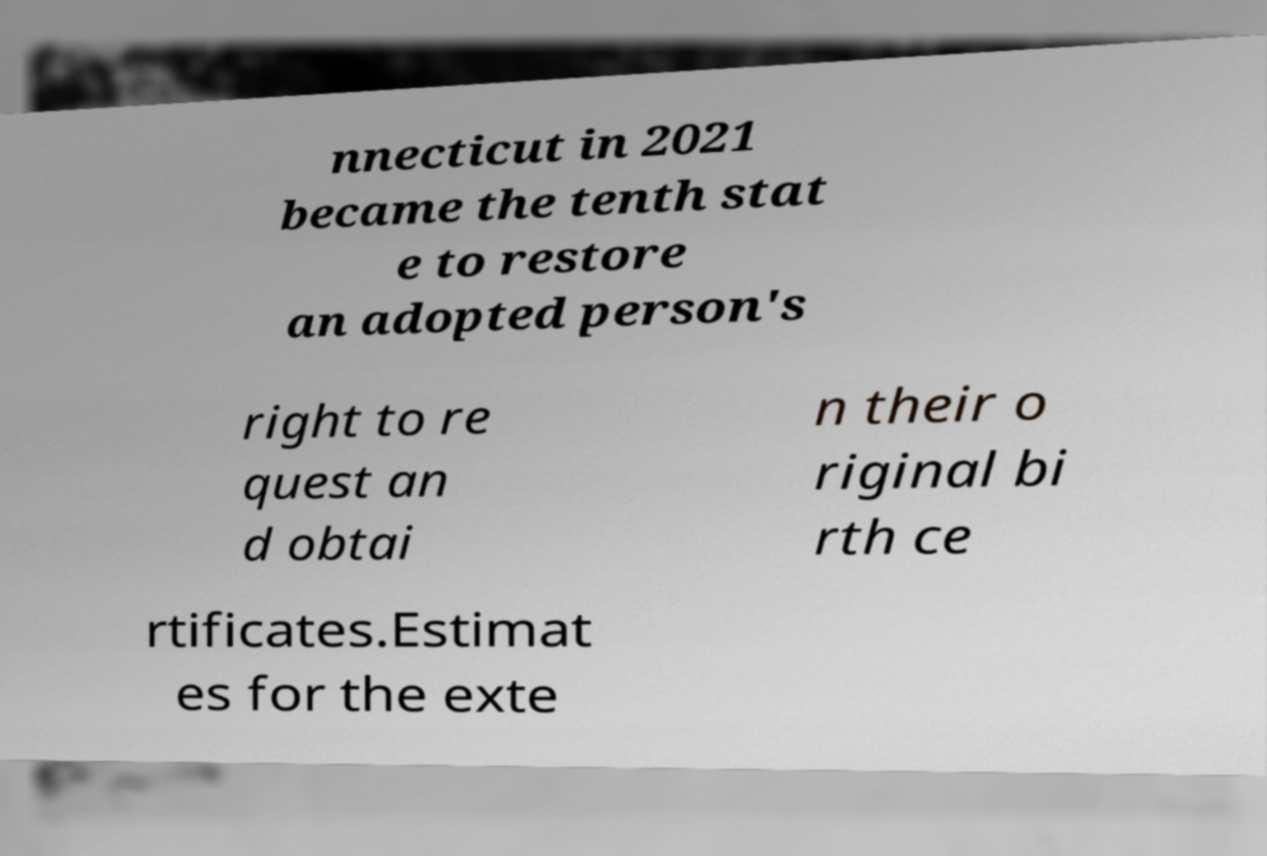Please read and relay the text visible in this image. What does it say? nnecticut in 2021 became the tenth stat e to restore an adopted person's right to re quest an d obtai n their o riginal bi rth ce rtificates.Estimat es for the exte 